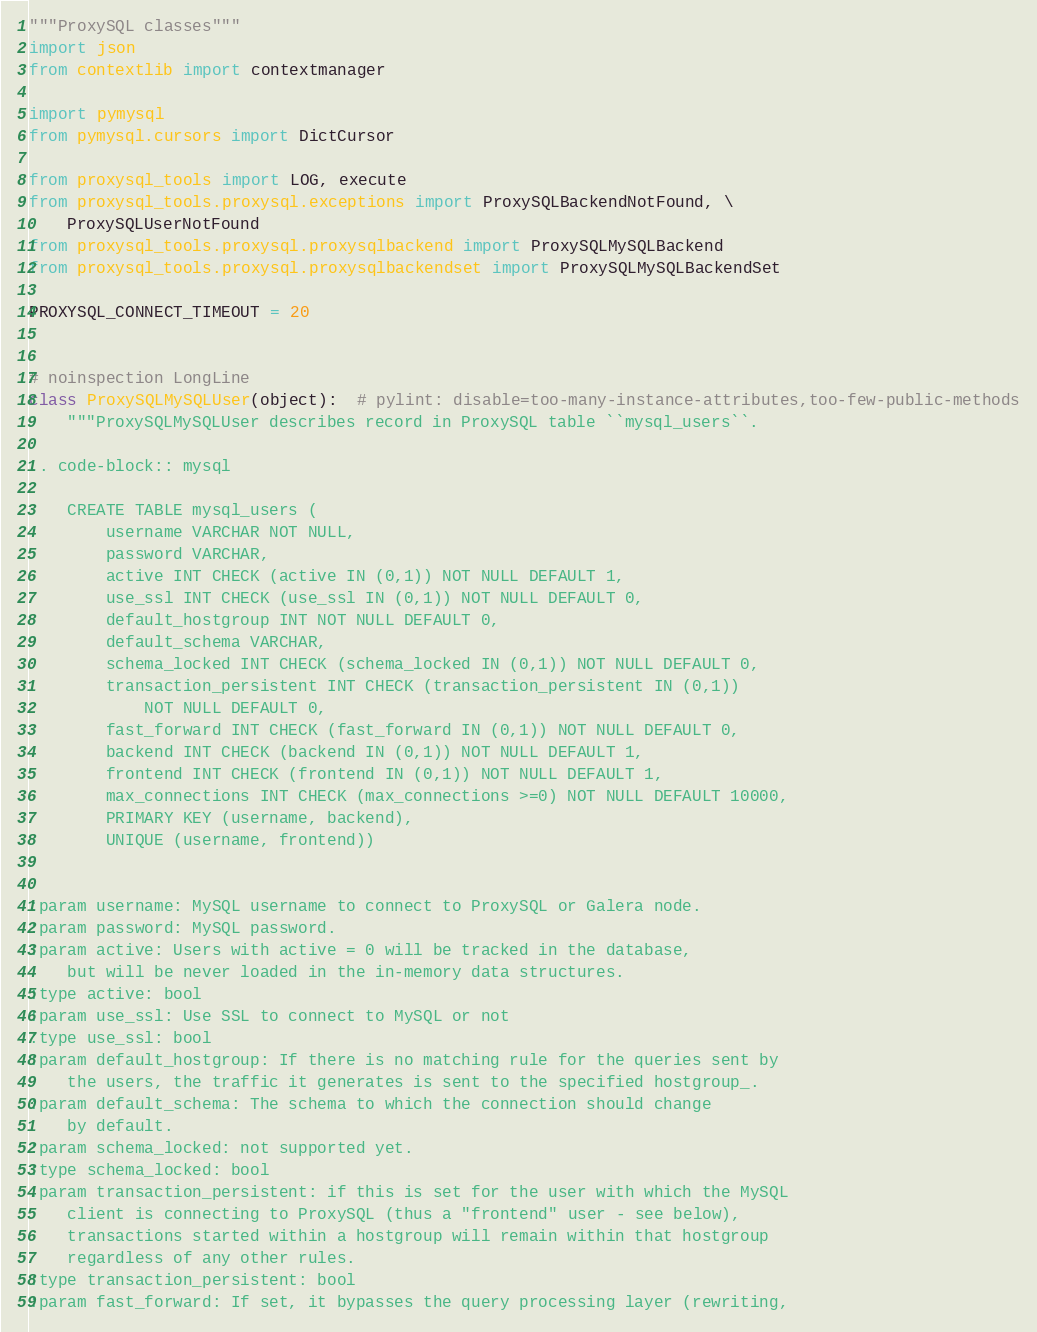Convert code to text. <code><loc_0><loc_0><loc_500><loc_500><_Python_>"""ProxySQL classes"""
import json
from contextlib import contextmanager

import pymysql
from pymysql.cursors import DictCursor

from proxysql_tools import LOG, execute
from proxysql_tools.proxysql.exceptions import ProxySQLBackendNotFound, \
    ProxySQLUserNotFound
from proxysql_tools.proxysql.proxysqlbackend import ProxySQLMySQLBackend
from proxysql_tools.proxysql.proxysqlbackendset import ProxySQLMySQLBackendSet

PROXYSQL_CONNECT_TIMEOUT = 20


# noinspection LongLine
class ProxySQLMySQLUser(object):  # pylint: disable=too-many-instance-attributes,too-few-public-methods
    """ProxySQLMySQLUser describes record in ProxySQL table ``mysql_users``.

.. code-block:: mysql

    CREATE TABLE mysql_users (
        username VARCHAR NOT NULL,
        password VARCHAR,
        active INT CHECK (active IN (0,1)) NOT NULL DEFAULT 1,
        use_ssl INT CHECK (use_ssl IN (0,1)) NOT NULL DEFAULT 0,
        default_hostgroup INT NOT NULL DEFAULT 0,
        default_schema VARCHAR,
        schema_locked INT CHECK (schema_locked IN (0,1)) NOT NULL DEFAULT 0,
        transaction_persistent INT CHECK (transaction_persistent IN (0,1))
            NOT NULL DEFAULT 0,
        fast_forward INT CHECK (fast_forward IN (0,1)) NOT NULL DEFAULT 0,
        backend INT CHECK (backend IN (0,1)) NOT NULL DEFAULT 1,
        frontend INT CHECK (frontend IN (0,1)) NOT NULL DEFAULT 1,
        max_connections INT CHECK (max_connections >=0) NOT NULL DEFAULT 10000,
        PRIMARY KEY (username, backend),
        UNIQUE (username, frontend))


:param username: MySQL username to connect to ProxySQL or Galera node.
:param password: MySQL password.
:param active: Users with active = 0 will be tracked in the database,
    but will be never loaded in the in-memory data structures.
:type active: bool
:param use_ssl: Use SSL to connect to MySQL or not
:type use_ssl: bool
:param default_hostgroup: If there is no matching rule for the queries sent by
    the users, the traffic it generates is sent to the specified hostgroup_.
:param default_schema: The schema to which the connection should change
    by default.
:param schema_locked: not supported yet.
:type schema_locked: bool
:param transaction_persistent: if this is set for the user with which the MySQL
    client is connecting to ProxySQL (thus a "frontend" user - see below),
    transactions started within a hostgroup will remain within that hostgroup
    regardless of any other rules.
:type transaction_persistent: bool
:param fast_forward: If set, it bypasses the query processing layer (rewriting,</code> 